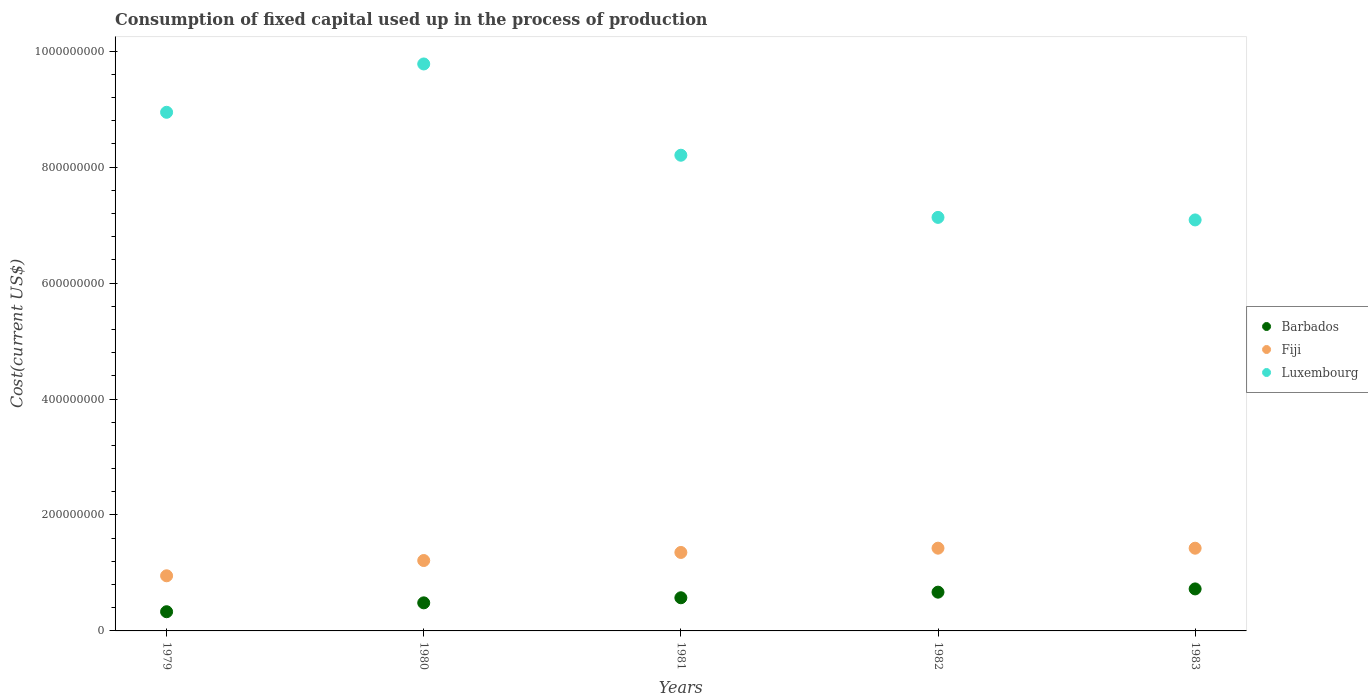What is the amount consumed in the process of production in Fiji in 1980?
Provide a short and direct response. 1.21e+08. Across all years, what is the maximum amount consumed in the process of production in Barbados?
Your answer should be compact. 7.25e+07. Across all years, what is the minimum amount consumed in the process of production in Barbados?
Offer a terse response. 3.31e+07. In which year was the amount consumed in the process of production in Fiji minimum?
Make the answer very short. 1979. What is the total amount consumed in the process of production in Barbados in the graph?
Make the answer very short. 2.78e+08. What is the difference between the amount consumed in the process of production in Luxembourg in 1980 and that in 1983?
Give a very brief answer. 2.69e+08. What is the difference between the amount consumed in the process of production in Fiji in 1983 and the amount consumed in the process of production in Luxembourg in 1982?
Offer a very short reply. -5.71e+08. What is the average amount consumed in the process of production in Fiji per year?
Provide a succinct answer. 1.27e+08. In the year 1981, what is the difference between the amount consumed in the process of production in Luxembourg and amount consumed in the process of production in Barbados?
Offer a very short reply. 7.63e+08. What is the ratio of the amount consumed in the process of production in Fiji in 1980 to that in 1982?
Give a very brief answer. 0.85. Is the difference between the amount consumed in the process of production in Luxembourg in 1979 and 1982 greater than the difference between the amount consumed in the process of production in Barbados in 1979 and 1982?
Give a very brief answer. Yes. What is the difference between the highest and the second highest amount consumed in the process of production in Fiji?
Keep it short and to the point. 5.72e+04. What is the difference between the highest and the lowest amount consumed in the process of production in Barbados?
Keep it short and to the point. 3.93e+07. In how many years, is the amount consumed in the process of production in Fiji greater than the average amount consumed in the process of production in Fiji taken over all years?
Your answer should be very brief. 3. Is the amount consumed in the process of production in Barbados strictly greater than the amount consumed in the process of production in Fiji over the years?
Give a very brief answer. No. Is the amount consumed in the process of production in Fiji strictly less than the amount consumed in the process of production in Barbados over the years?
Keep it short and to the point. No. How many dotlines are there?
Keep it short and to the point. 3. How many years are there in the graph?
Keep it short and to the point. 5. What is the difference between two consecutive major ticks on the Y-axis?
Ensure brevity in your answer.  2.00e+08. Does the graph contain grids?
Your answer should be compact. No. What is the title of the graph?
Provide a succinct answer. Consumption of fixed capital used up in the process of production. What is the label or title of the X-axis?
Ensure brevity in your answer.  Years. What is the label or title of the Y-axis?
Provide a succinct answer. Cost(current US$). What is the Cost(current US$) in Barbados in 1979?
Provide a short and direct response. 3.31e+07. What is the Cost(current US$) of Fiji in 1979?
Ensure brevity in your answer.  9.51e+07. What is the Cost(current US$) of Luxembourg in 1979?
Your response must be concise. 8.95e+08. What is the Cost(current US$) of Barbados in 1980?
Offer a terse response. 4.84e+07. What is the Cost(current US$) in Fiji in 1980?
Your response must be concise. 1.21e+08. What is the Cost(current US$) of Luxembourg in 1980?
Give a very brief answer. 9.78e+08. What is the Cost(current US$) of Barbados in 1981?
Offer a terse response. 5.72e+07. What is the Cost(current US$) in Fiji in 1981?
Offer a terse response. 1.35e+08. What is the Cost(current US$) in Luxembourg in 1981?
Offer a very short reply. 8.20e+08. What is the Cost(current US$) of Barbados in 1982?
Keep it short and to the point. 6.69e+07. What is the Cost(current US$) in Fiji in 1982?
Ensure brevity in your answer.  1.43e+08. What is the Cost(current US$) in Luxembourg in 1982?
Offer a terse response. 7.13e+08. What is the Cost(current US$) in Barbados in 1983?
Your answer should be very brief. 7.25e+07. What is the Cost(current US$) in Fiji in 1983?
Your response must be concise. 1.43e+08. What is the Cost(current US$) of Luxembourg in 1983?
Make the answer very short. 7.09e+08. Across all years, what is the maximum Cost(current US$) in Barbados?
Your answer should be compact. 7.25e+07. Across all years, what is the maximum Cost(current US$) of Fiji?
Keep it short and to the point. 1.43e+08. Across all years, what is the maximum Cost(current US$) in Luxembourg?
Your answer should be compact. 9.78e+08. Across all years, what is the minimum Cost(current US$) in Barbados?
Offer a very short reply. 3.31e+07. Across all years, what is the minimum Cost(current US$) of Fiji?
Provide a short and direct response. 9.51e+07. Across all years, what is the minimum Cost(current US$) of Luxembourg?
Your response must be concise. 7.09e+08. What is the total Cost(current US$) in Barbados in the graph?
Provide a short and direct response. 2.78e+08. What is the total Cost(current US$) in Fiji in the graph?
Ensure brevity in your answer.  6.37e+08. What is the total Cost(current US$) in Luxembourg in the graph?
Offer a terse response. 4.11e+09. What is the difference between the Cost(current US$) in Barbados in 1979 and that in 1980?
Your answer should be very brief. -1.53e+07. What is the difference between the Cost(current US$) of Fiji in 1979 and that in 1980?
Make the answer very short. -2.63e+07. What is the difference between the Cost(current US$) in Luxembourg in 1979 and that in 1980?
Provide a short and direct response. -8.34e+07. What is the difference between the Cost(current US$) in Barbados in 1979 and that in 1981?
Ensure brevity in your answer.  -2.41e+07. What is the difference between the Cost(current US$) of Fiji in 1979 and that in 1981?
Give a very brief answer. -4.02e+07. What is the difference between the Cost(current US$) of Luxembourg in 1979 and that in 1981?
Give a very brief answer. 7.40e+07. What is the difference between the Cost(current US$) of Barbados in 1979 and that in 1982?
Ensure brevity in your answer.  -3.38e+07. What is the difference between the Cost(current US$) in Fiji in 1979 and that in 1982?
Your answer should be very brief. -4.76e+07. What is the difference between the Cost(current US$) in Luxembourg in 1979 and that in 1982?
Your answer should be compact. 1.81e+08. What is the difference between the Cost(current US$) in Barbados in 1979 and that in 1983?
Keep it short and to the point. -3.93e+07. What is the difference between the Cost(current US$) in Fiji in 1979 and that in 1983?
Provide a short and direct response. -4.76e+07. What is the difference between the Cost(current US$) of Luxembourg in 1979 and that in 1983?
Provide a succinct answer. 1.86e+08. What is the difference between the Cost(current US$) in Barbados in 1980 and that in 1981?
Make the answer very short. -8.77e+06. What is the difference between the Cost(current US$) in Fiji in 1980 and that in 1981?
Offer a terse response. -1.39e+07. What is the difference between the Cost(current US$) of Luxembourg in 1980 and that in 1981?
Give a very brief answer. 1.57e+08. What is the difference between the Cost(current US$) of Barbados in 1980 and that in 1982?
Offer a very short reply. -1.84e+07. What is the difference between the Cost(current US$) in Fiji in 1980 and that in 1982?
Ensure brevity in your answer.  -2.13e+07. What is the difference between the Cost(current US$) in Luxembourg in 1980 and that in 1982?
Provide a short and direct response. 2.65e+08. What is the difference between the Cost(current US$) of Barbados in 1980 and that in 1983?
Your answer should be very brief. -2.40e+07. What is the difference between the Cost(current US$) of Fiji in 1980 and that in 1983?
Your answer should be very brief. -2.12e+07. What is the difference between the Cost(current US$) in Luxembourg in 1980 and that in 1983?
Provide a short and direct response. 2.69e+08. What is the difference between the Cost(current US$) of Barbados in 1981 and that in 1982?
Your answer should be compact. -9.67e+06. What is the difference between the Cost(current US$) in Fiji in 1981 and that in 1982?
Give a very brief answer. -7.38e+06. What is the difference between the Cost(current US$) in Luxembourg in 1981 and that in 1982?
Provide a short and direct response. 1.07e+08. What is the difference between the Cost(current US$) of Barbados in 1981 and that in 1983?
Offer a very short reply. -1.53e+07. What is the difference between the Cost(current US$) of Fiji in 1981 and that in 1983?
Give a very brief answer. -7.32e+06. What is the difference between the Cost(current US$) in Luxembourg in 1981 and that in 1983?
Provide a succinct answer. 1.12e+08. What is the difference between the Cost(current US$) in Barbados in 1982 and that in 1983?
Keep it short and to the point. -5.59e+06. What is the difference between the Cost(current US$) of Fiji in 1982 and that in 1983?
Ensure brevity in your answer.  5.72e+04. What is the difference between the Cost(current US$) in Luxembourg in 1982 and that in 1983?
Offer a very short reply. 4.39e+06. What is the difference between the Cost(current US$) in Barbados in 1979 and the Cost(current US$) in Fiji in 1980?
Keep it short and to the point. -8.83e+07. What is the difference between the Cost(current US$) of Barbados in 1979 and the Cost(current US$) of Luxembourg in 1980?
Ensure brevity in your answer.  -9.45e+08. What is the difference between the Cost(current US$) of Fiji in 1979 and the Cost(current US$) of Luxembourg in 1980?
Your response must be concise. -8.83e+08. What is the difference between the Cost(current US$) of Barbados in 1979 and the Cost(current US$) of Fiji in 1981?
Make the answer very short. -1.02e+08. What is the difference between the Cost(current US$) of Barbados in 1979 and the Cost(current US$) of Luxembourg in 1981?
Give a very brief answer. -7.87e+08. What is the difference between the Cost(current US$) of Fiji in 1979 and the Cost(current US$) of Luxembourg in 1981?
Offer a very short reply. -7.25e+08. What is the difference between the Cost(current US$) in Barbados in 1979 and the Cost(current US$) in Fiji in 1982?
Your answer should be very brief. -1.10e+08. What is the difference between the Cost(current US$) of Barbados in 1979 and the Cost(current US$) of Luxembourg in 1982?
Give a very brief answer. -6.80e+08. What is the difference between the Cost(current US$) of Fiji in 1979 and the Cost(current US$) of Luxembourg in 1982?
Your answer should be very brief. -6.18e+08. What is the difference between the Cost(current US$) in Barbados in 1979 and the Cost(current US$) in Fiji in 1983?
Offer a very short reply. -1.10e+08. What is the difference between the Cost(current US$) in Barbados in 1979 and the Cost(current US$) in Luxembourg in 1983?
Your answer should be compact. -6.76e+08. What is the difference between the Cost(current US$) in Fiji in 1979 and the Cost(current US$) in Luxembourg in 1983?
Give a very brief answer. -6.14e+08. What is the difference between the Cost(current US$) in Barbados in 1980 and the Cost(current US$) in Fiji in 1981?
Make the answer very short. -8.69e+07. What is the difference between the Cost(current US$) of Barbados in 1980 and the Cost(current US$) of Luxembourg in 1981?
Give a very brief answer. -7.72e+08. What is the difference between the Cost(current US$) in Fiji in 1980 and the Cost(current US$) in Luxembourg in 1981?
Ensure brevity in your answer.  -6.99e+08. What is the difference between the Cost(current US$) in Barbados in 1980 and the Cost(current US$) in Fiji in 1982?
Your response must be concise. -9.43e+07. What is the difference between the Cost(current US$) of Barbados in 1980 and the Cost(current US$) of Luxembourg in 1982?
Make the answer very short. -6.65e+08. What is the difference between the Cost(current US$) of Fiji in 1980 and the Cost(current US$) of Luxembourg in 1982?
Provide a short and direct response. -5.92e+08. What is the difference between the Cost(current US$) of Barbados in 1980 and the Cost(current US$) of Fiji in 1983?
Ensure brevity in your answer.  -9.42e+07. What is the difference between the Cost(current US$) of Barbados in 1980 and the Cost(current US$) of Luxembourg in 1983?
Offer a very short reply. -6.60e+08. What is the difference between the Cost(current US$) of Fiji in 1980 and the Cost(current US$) of Luxembourg in 1983?
Provide a short and direct response. -5.87e+08. What is the difference between the Cost(current US$) in Barbados in 1981 and the Cost(current US$) in Fiji in 1982?
Give a very brief answer. -8.55e+07. What is the difference between the Cost(current US$) of Barbados in 1981 and the Cost(current US$) of Luxembourg in 1982?
Keep it short and to the point. -6.56e+08. What is the difference between the Cost(current US$) of Fiji in 1981 and the Cost(current US$) of Luxembourg in 1982?
Offer a terse response. -5.78e+08. What is the difference between the Cost(current US$) of Barbados in 1981 and the Cost(current US$) of Fiji in 1983?
Provide a short and direct response. -8.55e+07. What is the difference between the Cost(current US$) in Barbados in 1981 and the Cost(current US$) in Luxembourg in 1983?
Provide a succinct answer. -6.52e+08. What is the difference between the Cost(current US$) of Fiji in 1981 and the Cost(current US$) of Luxembourg in 1983?
Provide a short and direct response. -5.74e+08. What is the difference between the Cost(current US$) in Barbados in 1982 and the Cost(current US$) in Fiji in 1983?
Ensure brevity in your answer.  -7.58e+07. What is the difference between the Cost(current US$) of Barbados in 1982 and the Cost(current US$) of Luxembourg in 1983?
Your response must be concise. -6.42e+08. What is the difference between the Cost(current US$) of Fiji in 1982 and the Cost(current US$) of Luxembourg in 1983?
Make the answer very short. -5.66e+08. What is the average Cost(current US$) in Barbados per year?
Make the answer very short. 5.56e+07. What is the average Cost(current US$) in Fiji per year?
Offer a very short reply. 1.27e+08. What is the average Cost(current US$) in Luxembourg per year?
Offer a terse response. 8.23e+08. In the year 1979, what is the difference between the Cost(current US$) in Barbados and Cost(current US$) in Fiji?
Offer a terse response. -6.20e+07. In the year 1979, what is the difference between the Cost(current US$) in Barbados and Cost(current US$) in Luxembourg?
Ensure brevity in your answer.  -8.61e+08. In the year 1979, what is the difference between the Cost(current US$) of Fiji and Cost(current US$) of Luxembourg?
Give a very brief answer. -7.99e+08. In the year 1980, what is the difference between the Cost(current US$) in Barbados and Cost(current US$) in Fiji?
Give a very brief answer. -7.30e+07. In the year 1980, what is the difference between the Cost(current US$) of Barbados and Cost(current US$) of Luxembourg?
Keep it short and to the point. -9.29e+08. In the year 1980, what is the difference between the Cost(current US$) in Fiji and Cost(current US$) in Luxembourg?
Offer a very short reply. -8.56e+08. In the year 1981, what is the difference between the Cost(current US$) of Barbados and Cost(current US$) of Fiji?
Offer a very short reply. -7.82e+07. In the year 1981, what is the difference between the Cost(current US$) in Barbados and Cost(current US$) in Luxembourg?
Provide a succinct answer. -7.63e+08. In the year 1981, what is the difference between the Cost(current US$) in Fiji and Cost(current US$) in Luxembourg?
Your answer should be very brief. -6.85e+08. In the year 1982, what is the difference between the Cost(current US$) in Barbados and Cost(current US$) in Fiji?
Offer a very short reply. -7.59e+07. In the year 1982, what is the difference between the Cost(current US$) of Barbados and Cost(current US$) of Luxembourg?
Make the answer very short. -6.46e+08. In the year 1982, what is the difference between the Cost(current US$) in Fiji and Cost(current US$) in Luxembourg?
Offer a terse response. -5.71e+08. In the year 1983, what is the difference between the Cost(current US$) in Barbados and Cost(current US$) in Fiji?
Give a very brief answer. -7.02e+07. In the year 1983, what is the difference between the Cost(current US$) of Barbados and Cost(current US$) of Luxembourg?
Provide a short and direct response. -6.36e+08. In the year 1983, what is the difference between the Cost(current US$) of Fiji and Cost(current US$) of Luxembourg?
Your response must be concise. -5.66e+08. What is the ratio of the Cost(current US$) in Barbados in 1979 to that in 1980?
Offer a very short reply. 0.68. What is the ratio of the Cost(current US$) in Fiji in 1979 to that in 1980?
Your response must be concise. 0.78. What is the ratio of the Cost(current US$) of Luxembourg in 1979 to that in 1980?
Your response must be concise. 0.91. What is the ratio of the Cost(current US$) in Barbados in 1979 to that in 1981?
Your answer should be very brief. 0.58. What is the ratio of the Cost(current US$) in Fiji in 1979 to that in 1981?
Your response must be concise. 0.7. What is the ratio of the Cost(current US$) in Luxembourg in 1979 to that in 1981?
Your answer should be very brief. 1.09. What is the ratio of the Cost(current US$) in Barbados in 1979 to that in 1982?
Offer a very short reply. 0.5. What is the ratio of the Cost(current US$) of Fiji in 1979 to that in 1982?
Offer a very short reply. 0.67. What is the ratio of the Cost(current US$) in Luxembourg in 1979 to that in 1982?
Provide a short and direct response. 1.25. What is the ratio of the Cost(current US$) of Barbados in 1979 to that in 1983?
Your answer should be compact. 0.46. What is the ratio of the Cost(current US$) of Fiji in 1979 to that in 1983?
Provide a short and direct response. 0.67. What is the ratio of the Cost(current US$) in Luxembourg in 1979 to that in 1983?
Provide a succinct answer. 1.26. What is the ratio of the Cost(current US$) in Barbados in 1980 to that in 1981?
Ensure brevity in your answer.  0.85. What is the ratio of the Cost(current US$) in Fiji in 1980 to that in 1981?
Your answer should be compact. 0.9. What is the ratio of the Cost(current US$) in Luxembourg in 1980 to that in 1981?
Provide a short and direct response. 1.19. What is the ratio of the Cost(current US$) of Barbados in 1980 to that in 1982?
Provide a succinct answer. 0.72. What is the ratio of the Cost(current US$) of Fiji in 1980 to that in 1982?
Ensure brevity in your answer.  0.85. What is the ratio of the Cost(current US$) of Luxembourg in 1980 to that in 1982?
Offer a very short reply. 1.37. What is the ratio of the Cost(current US$) in Barbados in 1980 to that in 1983?
Offer a very short reply. 0.67. What is the ratio of the Cost(current US$) of Fiji in 1980 to that in 1983?
Give a very brief answer. 0.85. What is the ratio of the Cost(current US$) in Luxembourg in 1980 to that in 1983?
Your response must be concise. 1.38. What is the ratio of the Cost(current US$) of Barbados in 1981 to that in 1982?
Ensure brevity in your answer.  0.86. What is the ratio of the Cost(current US$) of Fiji in 1981 to that in 1982?
Provide a short and direct response. 0.95. What is the ratio of the Cost(current US$) in Luxembourg in 1981 to that in 1982?
Your response must be concise. 1.15. What is the ratio of the Cost(current US$) in Barbados in 1981 to that in 1983?
Offer a very short reply. 0.79. What is the ratio of the Cost(current US$) in Fiji in 1981 to that in 1983?
Offer a terse response. 0.95. What is the ratio of the Cost(current US$) in Luxembourg in 1981 to that in 1983?
Provide a succinct answer. 1.16. What is the ratio of the Cost(current US$) in Barbados in 1982 to that in 1983?
Your response must be concise. 0.92. What is the ratio of the Cost(current US$) in Fiji in 1982 to that in 1983?
Provide a short and direct response. 1. What is the difference between the highest and the second highest Cost(current US$) in Barbados?
Provide a succinct answer. 5.59e+06. What is the difference between the highest and the second highest Cost(current US$) in Fiji?
Your response must be concise. 5.72e+04. What is the difference between the highest and the second highest Cost(current US$) in Luxembourg?
Offer a very short reply. 8.34e+07. What is the difference between the highest and the lowest Cost(current US$) in Barbados?
Provide a short and direct response. 3.93e+07. What is the difference between the highest and the lowest Cost(current US$) of Fiji?
Make the answer very short. 4.76e+07. What is the difference between the highest and the lowest Cost(current US$) of Luxembourg?
Provide a short and direct response. 2.69e+08. 